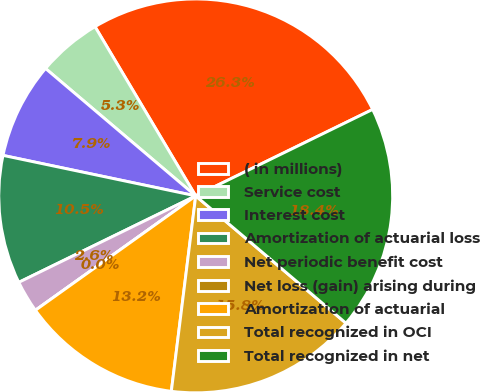<chart> <loc_0><loc_0><loc_500><loc_500><pie_chart><fcel>( in millions)<fcel>Service cost<fcel>Interest cost<fcel>Amortization of actuarial loss<fcel>Net periodic benefit cost<fcel>Net loss (gain) arising during<fcel>Amortization of actuarial<fcel>Total recognized in OCI<fcel>Total recognized in net<nl><fcel>26.31%<fcel>5.26%<fcel>7.9%<fcel>10.53%<fcel>2.63%<fcel>0.0%<fcel>13.16%<fcel>15.79%<fcel>18.42%<nl></chart> 